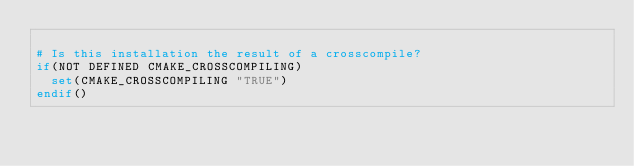<code> <loc_0><loc_0><loc_500><loc_500><_CMake_>
# Is this installation the result of a crosscompile?
if(NOT DEFINED CMAKE_CROSSCOMPILING)
  set(CMAKE_CROSSCOMPILING "TRUE")
endif()

</code> 